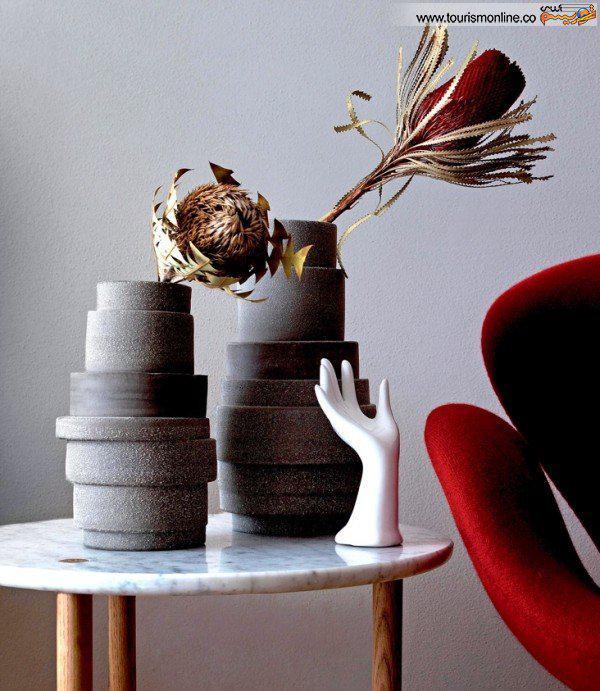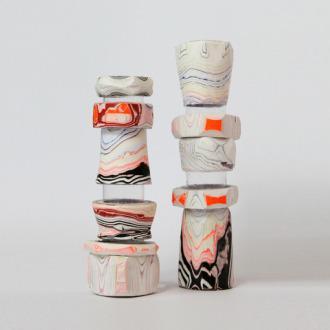The first image is the image on the left, the second image is the image on the right. Examine the images to the left and right. Is the description "At least one of the vases contains a plant with leaves." accurate? Answer yes or no. Yes. 